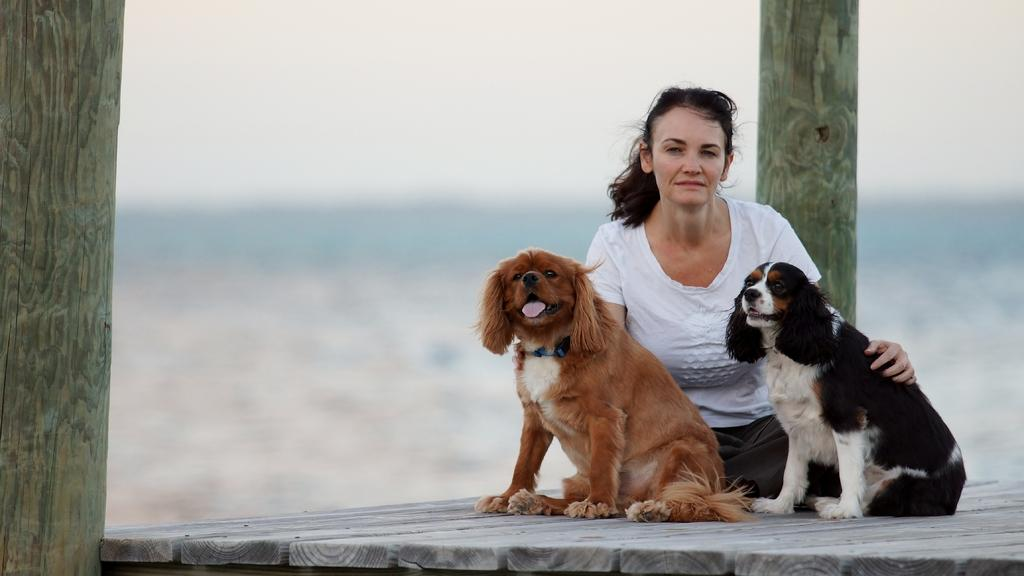What is the main subject of the image? The main subject of the image is a woman. Can you describe what the woman is wearing? The woman is wearing a white t-shirt. What else is present in the image besides the woman? There are dogs in front of the woman. What type of boat can be seen in the image? There is no boat present in the image. What scientific discovery can be observed in the image? There is no scientific discovery visible in the image. 